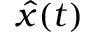<formula> <loc_0><loc_0><loc_500><loc_500>{ \hat { x } } ( t )</formula> 